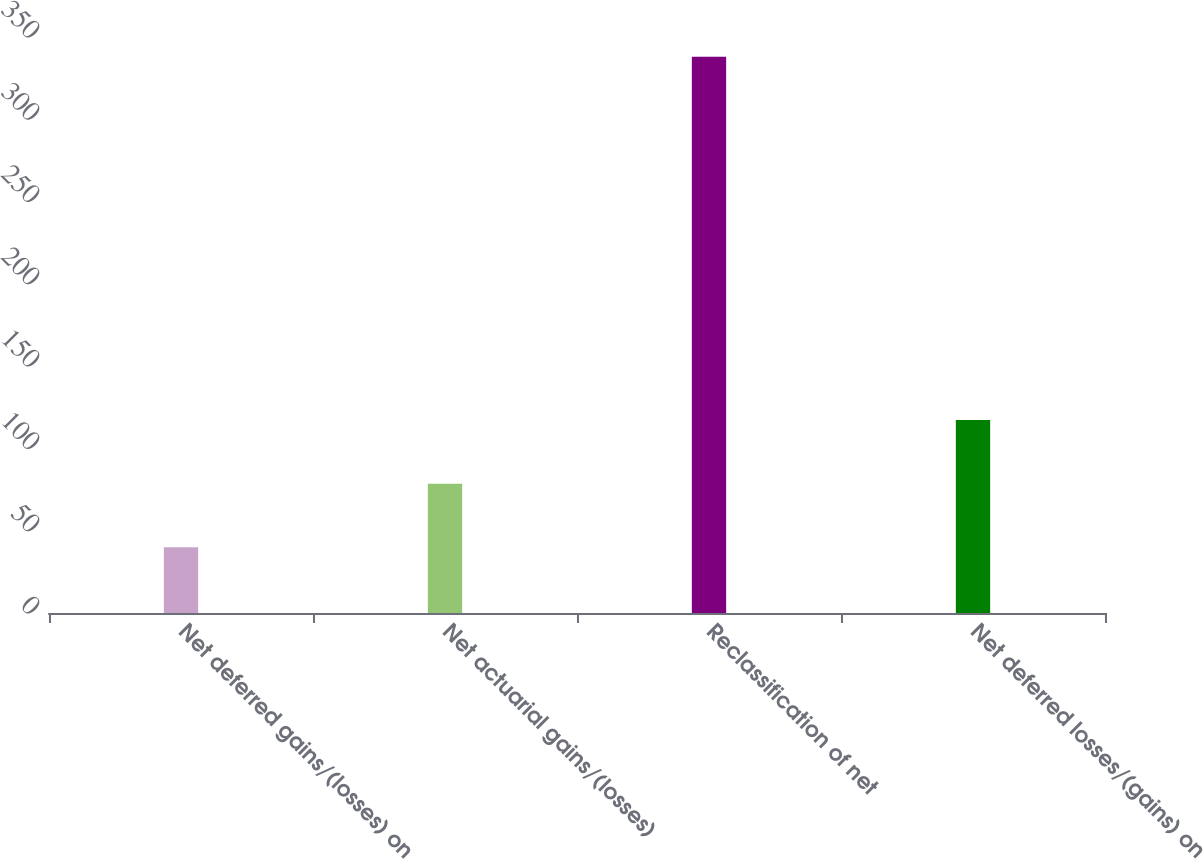Convert chart. <chart><loc_0><loc_0><loc_500><loc_500><bar_chart><fcel>Net deferred gains/(losses) on<fcel>Net actuarial gains/(losses)<fcel>Reclassification of net<fcel>Net deferred losses/(gains) on<nl><fcel>40<fcel>78.6<fcel>338<fcel>117.2<nl></chart> 